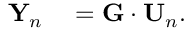<formula> <loc_0><loc_0><loc_500><loc_500>\begin{array} { r l } { { Y } _ { n } } & = { G } \cdot { U } _ { n } . } \end{array}</formula> 